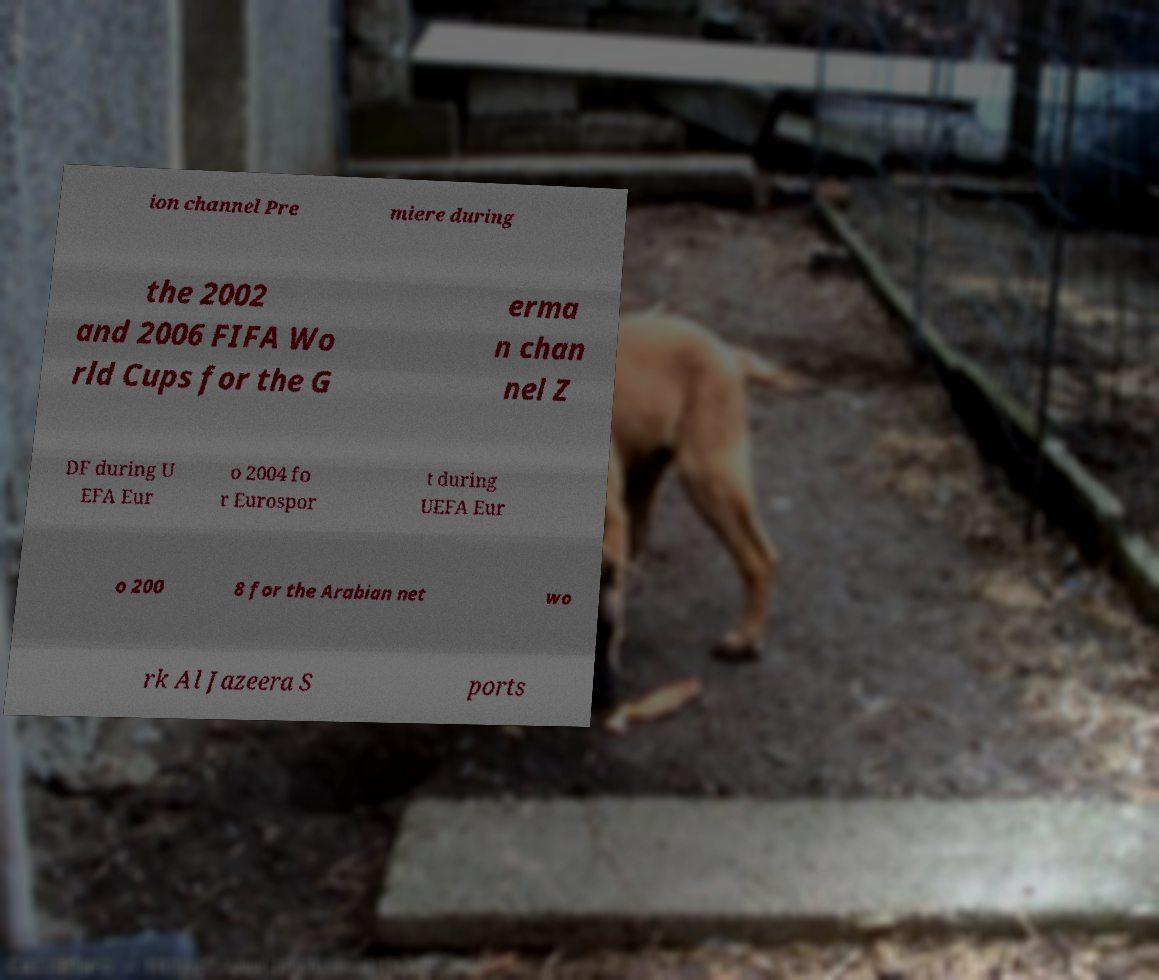Please identify and transcribe the text found in this image. ion channel Pre miere during the 2002 and 2006 FIFA Wo rld Cups for the G erma n chan nel Z DF during U EFA Eur o 2004 fo r Eurospor t during UEFA Eur o 200 8 for the Arabian net wo rk Al Jazeera S ports 